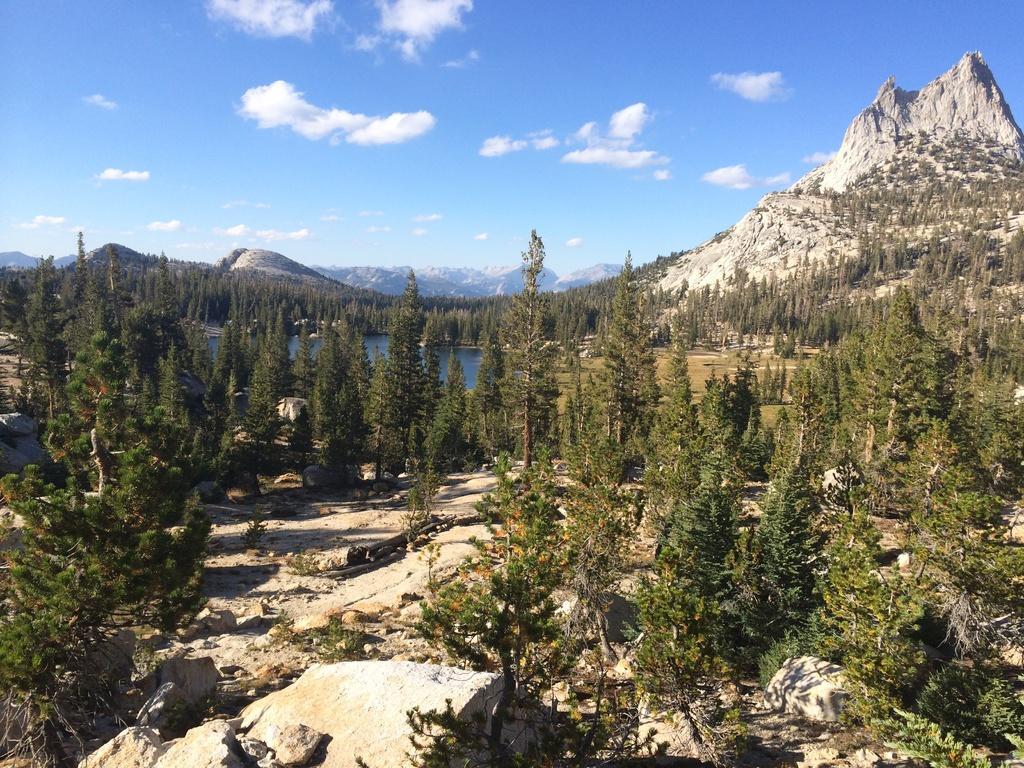Describe this image in one or two sentences. In the picture we can see a surface with trees, plants and behind it, we can see a water, a mountain with a rock and behind it we can see a sky with clouds. 